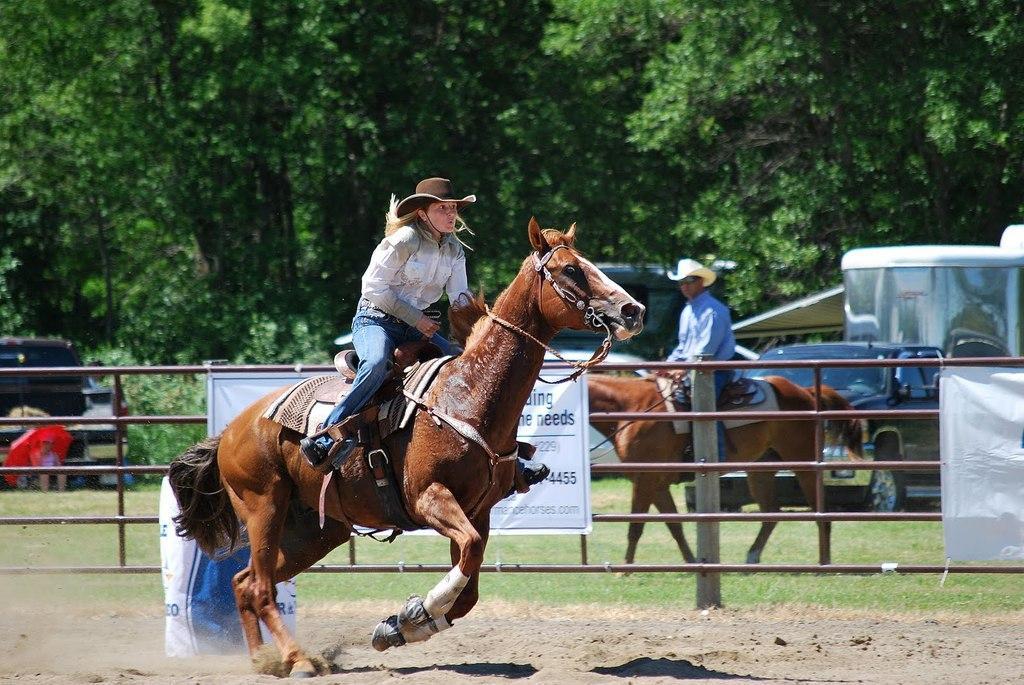Can you describe this image briefly? Here we can see two persons on the horse. This is grass. Here we can see some vehicles. On the background there are trees and this is banner. 